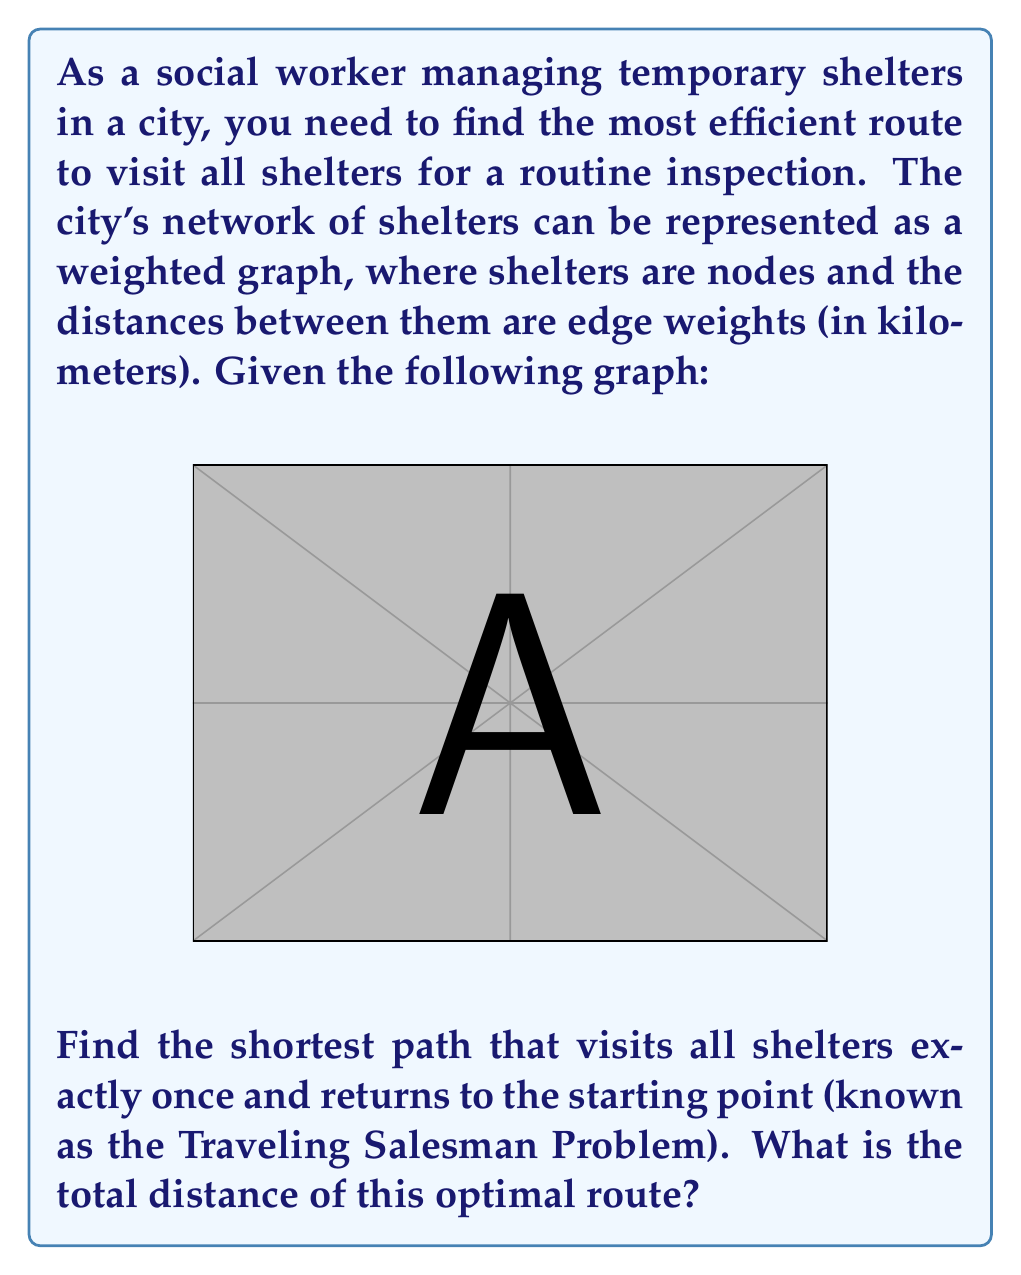Can you solve this math problem? To solve this Traveling Salesman Problem (TSP) for a small graph like this, we can use a brute-force approach to check all possible routes.

1. List all possible permutations of the 5 shelters (A, B, C, D, E).
2. For each permutation, calculate the total distance of the route.
3. Choose the route with the minimum total distance.

There are 5! = 120 possible permutations, but we can reduce this by fixing A as the starting point and considering rotations as equivalent. This leaves us with (5-1)! / 2 = 12 unique routes to check.

Let's calculate the distance for a few example routes:

1. A-B-C-D-E-A: 4 + 3 + 3 + 3 + 5 = 18 km
2. A-B-C-E-D-A: 4 + 3 + 2 + 3 + 5 = 17 km
3. A-B-D-C-E-A: 4 + 4 + 3 + 2 + 5 = 18 km
4. A-D-B-C-E-A: 5 + 4 + 3 + 2 + 5 = 19 km

After checking all possible routes, we find that the optimal route is:

A → B → C → E → D → A

The total distance of this route is:

$$4 + 3 + 2 + 3 + 5 = 17 \text{ km}$$

This route minimizes the total distance while visiting all shelters exactly once and returning to the starting point.
Answer: The shortest path visiting all shelters exactly once and returning to the starting point is A → B → C → E → D → A, with a total distance of 17 km. 